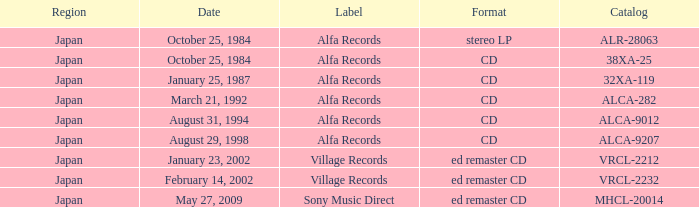Help me parse the entirety of this table. {'header': ['Region', 'Date', 'Label', 'Format', 'Catalog'], 'rows': [['Japan', 'October 25, 1984', 'Alfa Records', 'stereo LP', 'ALR-28063'], ['Japan', 'October 25, 1984', 'Alfa Records', 'CD', '38XA-25'], ['Japan', 'January 25, 1987', 'Alfa Records', 'CD', '32XA-119'], ['Japan', 'March 21, 1992', 'Alfa Records', 'CD', 'ALCA-282'], ['Japan', 'August 31, 1994', 'Alfa Records', 'CD', 'ALCA-9012'], ['Japan', 'August 29, 1998', 'Alfa Records', 'CD', 'ALCA-9207'], ['Japan', 'January 23, 2002', 'Village Records', 'ed remaster CD', 'VRCL-2212'], ['Japan', 'February 14, 2002', 'Village Records', 'ed remaster CD', 'VRCL-2232'], ['Japan', 'May 27, 2009', 'Sony Music Direct', 'ed remaster CD', 'MHCL-20014']]} What are the catalogs of releases from Sony Music Direct? MHCL-20014. 